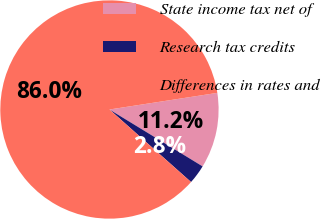<chart> <loc_0><loc_0><loc_500><loc_500><pie_chart><fcel>State income tax net of<fcel>Research tax credits<fcel>Differences in rates and<nl><fcel>11.16%<fcel>2.84%<fcel>86.0%<nl></chart> 